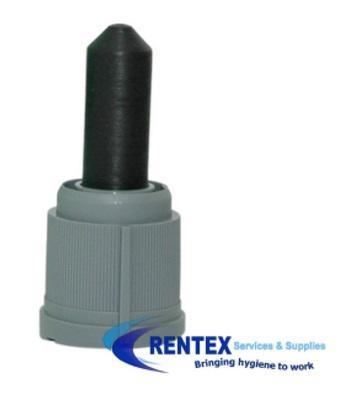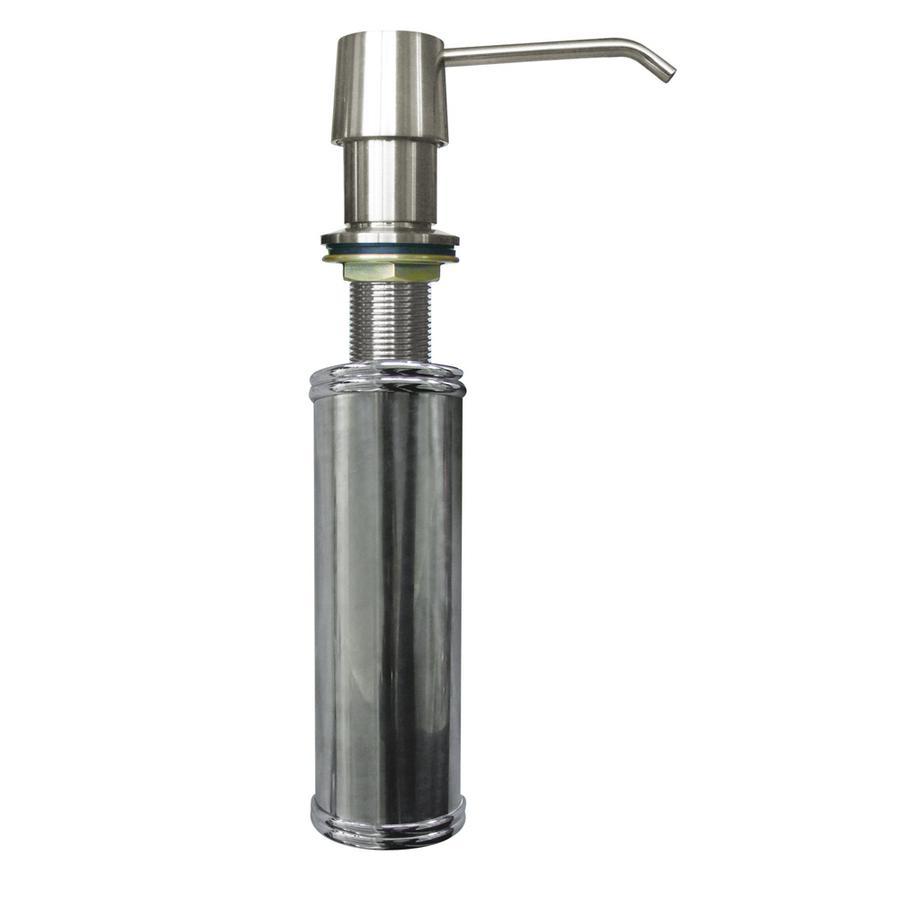The first image is the image on the left, the second image is the image on the right. Analyze the images presented: Is the assertion "The nozzle in the left image is silver colored." valid? Answer yes or no. No. 